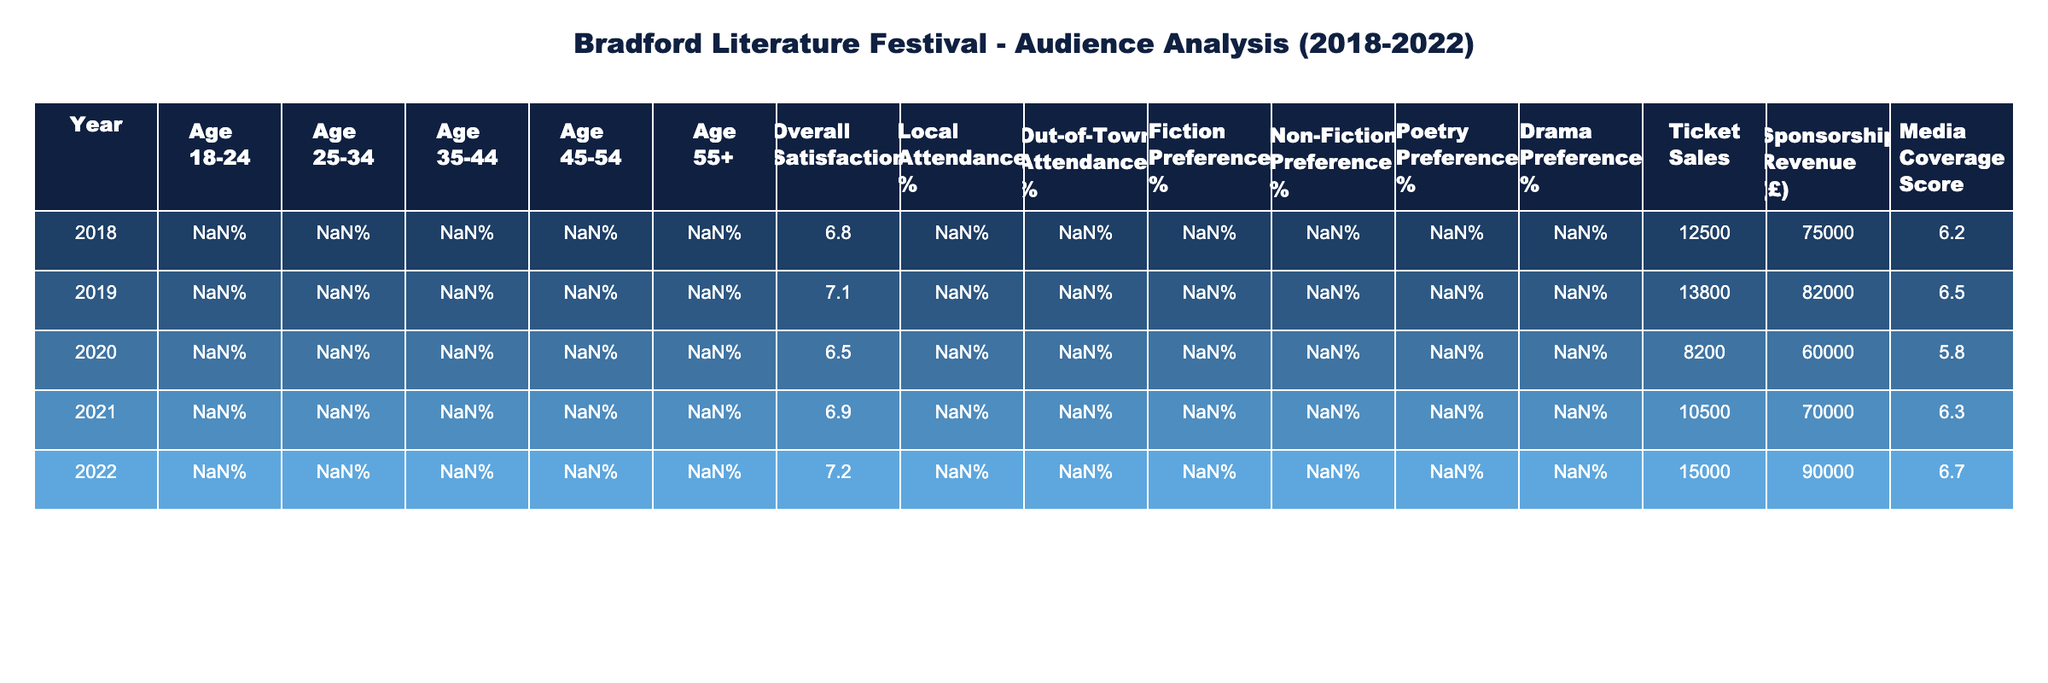What's the overall satisfaction score for 2020? The table shows the overall satisfaction score under the column "Overall Satisfaction" for the year 2020, which is 6.5.
Answer: 6.5 What percentage of local attendance was recorded in 2022? To find the local attendance in 2022, we look under the "Local Attendance %" column for that year, which indicates a percentage of 65%.
Answer: 65% Which year had the highest share of attendees aged 25-34? By examining the "Age 25-34" column across all years, the highest percentage is 25% in 2022.
Answer: 2022 What is the difference in overall satisfaction scores between 2018 and 2021? The overall satisfaction score in 2018 is 6.8 and in 2021 is 6.9. The difference is 6.9 - 6.8 = 0.1.
Answer: 0.1 Did the attendance from out-of-town attendees increase from 2018 to 2022? In 2018, out-of-town attendance was 28%, and in 2022 it was 35%. Since 35% is greater than 28%, it confirms an increase.
Answer: Yes What was the average ticket sales across these five years? Summing the ticket sales for each year: (12500 + 13800 + 8200 + 10500 + 15000) = 70000. Dividing by 5 years gives an average of 70000/5 = 14000.
Answer: 14000 What was the year with the lowest media coverage score? Looking in the "Media Coverage Score" column, the lowest score is 5.8 for the year 2020.
Answer: 2020 How does the fiction preference change from 2018 to 2022? In 2018, the fiction preference was 45%, and in 2022 it increased to 50%. The increase is 50% - 45% = 5%.
Answer: Increased by 5% Which age demographic had the least representation in 2019? Examining the age demographics in 2019, the least representation is in the 55+ age group, which is 16%.
Answer: Age 55+ Was the sponsorship revenue in 2021 greater than that in 2019? The sponsorship revenue for 2021 is £70000, while in 2019 it is £82000. Since 70000 is less than 82000, it is false.
Answer: No 